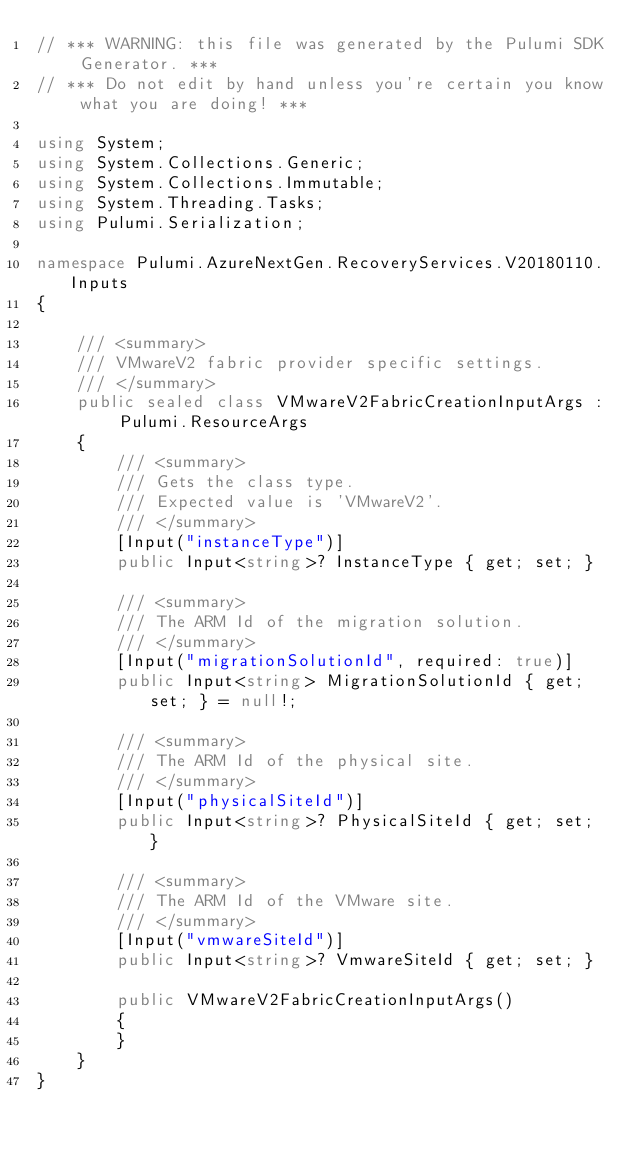<code> <loc_0><loc_0><loc_500><loc_500><_C#_>// *** WARNING: this file was generated by the Pulumi SDK Generator. ***
// *** Do not edit by hand unless you're certain you know what you are doing! ***

using System;
using System.Collections.Generic;
using System.Collections.Immutable;
using System.Threading.Tasks;
using Pulumi.Serialization;

namespace Pulumi.AzureNextGen.RecoveryServices.V20180110.Inputs
{

    /// <summary>
    /// VMwareV2 fabric provider specific settings.
    /// </summary>
    public sealed class VMwareV2FabricCreationInputArgs : Pulumi.ResourceArgs
    {
        /// <summary>
        /// Gets the class type.
        /// Expected value is 'VMwareV2'.
        /// </summary>
        [Input("instanceType")]
        public Input<string>? InstanceType { get; set; }

        /// <summary>
        /// The ARM Id of the migration solution.
        /// </summary>
        [Input("migrationSolutionId", required: true)]
        public Input<string> MigrationSolutionId { get; set; } = null!;

        /// <summary>
        /// The ARM Id of the physical site.
        /// </summary>
        [Input("physicalSiteId")]
        public Input<string>? PhysicalSiteId { get; set; }

        /// <summary>
        /// The ARM Id of the VMware site.
        /// </summary>
        [Input("vmwareSiteId")]
        public Input<string>? VmwareSiteId { get; set; }

        public VMwareV2FabricCreationInputArgs()
        {
        }
    }
}
</code> 